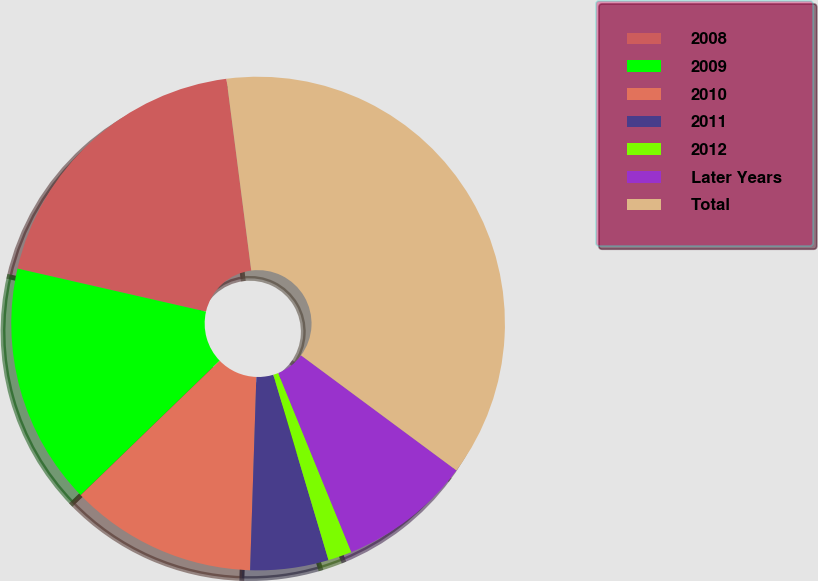Convert chart to OTSL. <chart><loc_0><loc_0><loc_500><loc_500><pie_chart><fcel>2008<fcel>2009<fcel>2010<fcel>2011<fcel>2012<fcel>Later Years<fcel>Total<nl><fcel>19.38%<fcel>15.81%<fcel>12.25%<fcel>5.12%<fcel>1.56%<fcel>8.69%<fcel>37.19%<nl></chart> 